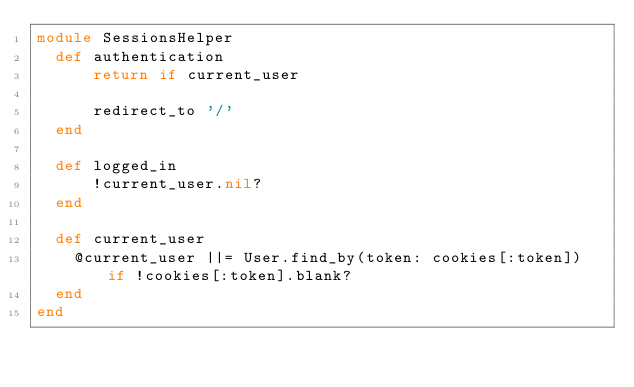<code> <loc_0><loc_0><loc_500><loc_500><_Ruby_>module SessionsHelper
  def authentication
      return if current_user

      redirect_to '/'
  end

  def logged_in
      !current_user.nil?
  end

  def current_user
    @current_user ||= User.find_by(token: cookies[:token]) if !cookies[:token].blank?
  end
end
</code> 